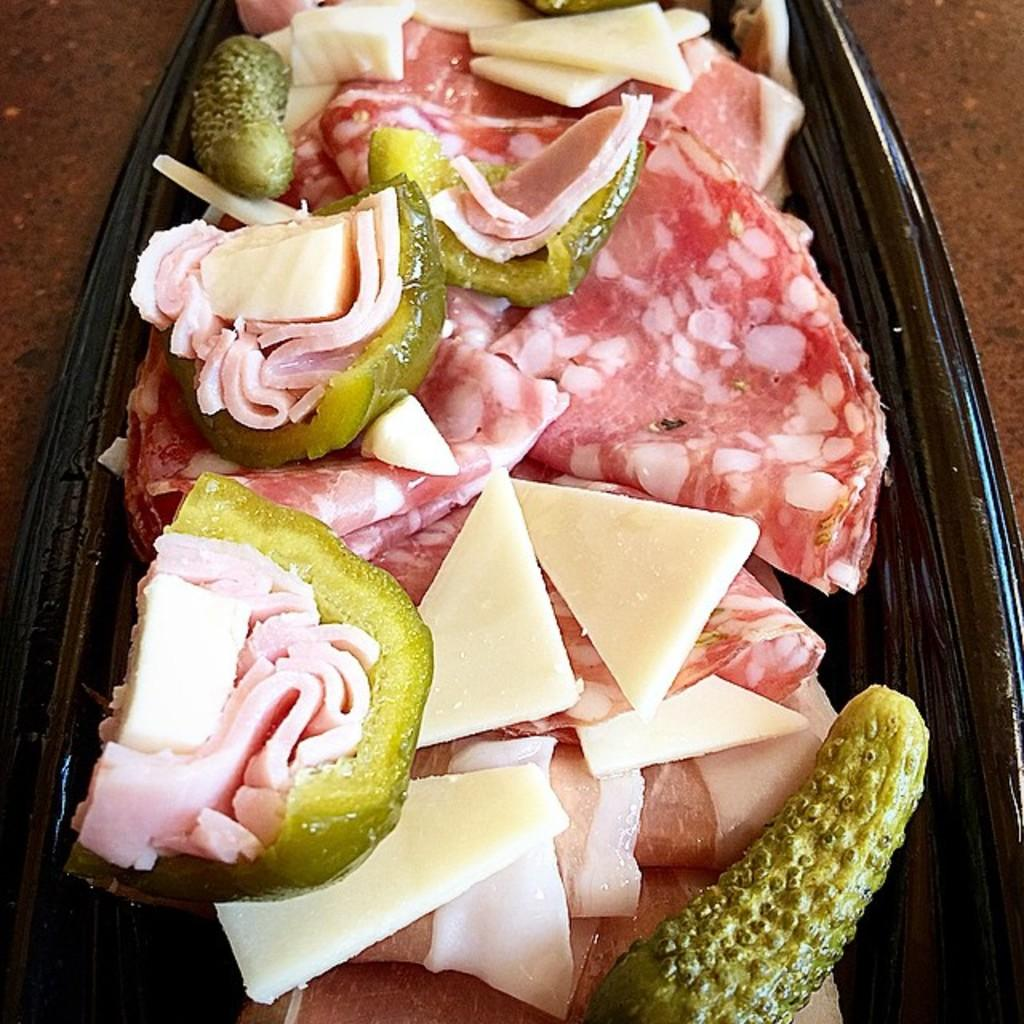What type of food can be seen in the image? There is meat, cheese, and cucumber in the image. Are there any other food items present in the image? The transcript mentions that there are other food items in the image. What color is the bowl that contains the food items? The food items are in a black bowl. Where is the black bowl placed? The black bowl is kept on a table. Can you see any cherries in the image? There are no cherries present in the image. Is there a monkey eating the food in the image? There is no monkey present in the image. 